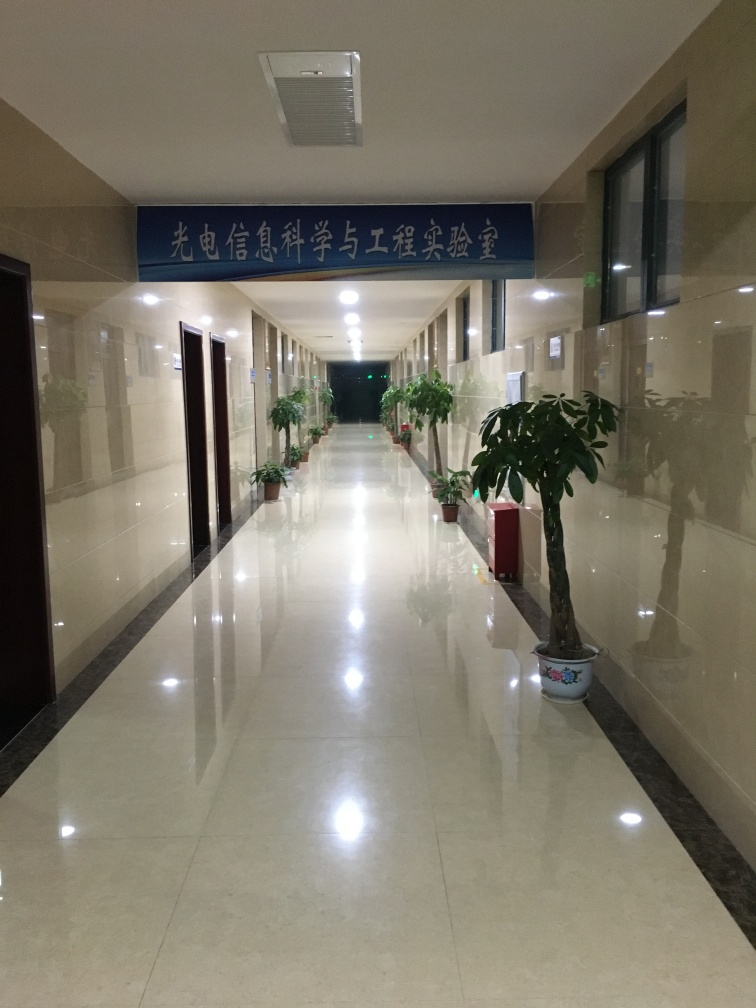Can you provide more details about this location? Based on the signage and the architectural features, it appears to be a corridor within a public or commercial building, possibly a hospital or educational institution. The use of indoor plants suggests an attempt to add a natural touch to an otherwise sterile environment. 